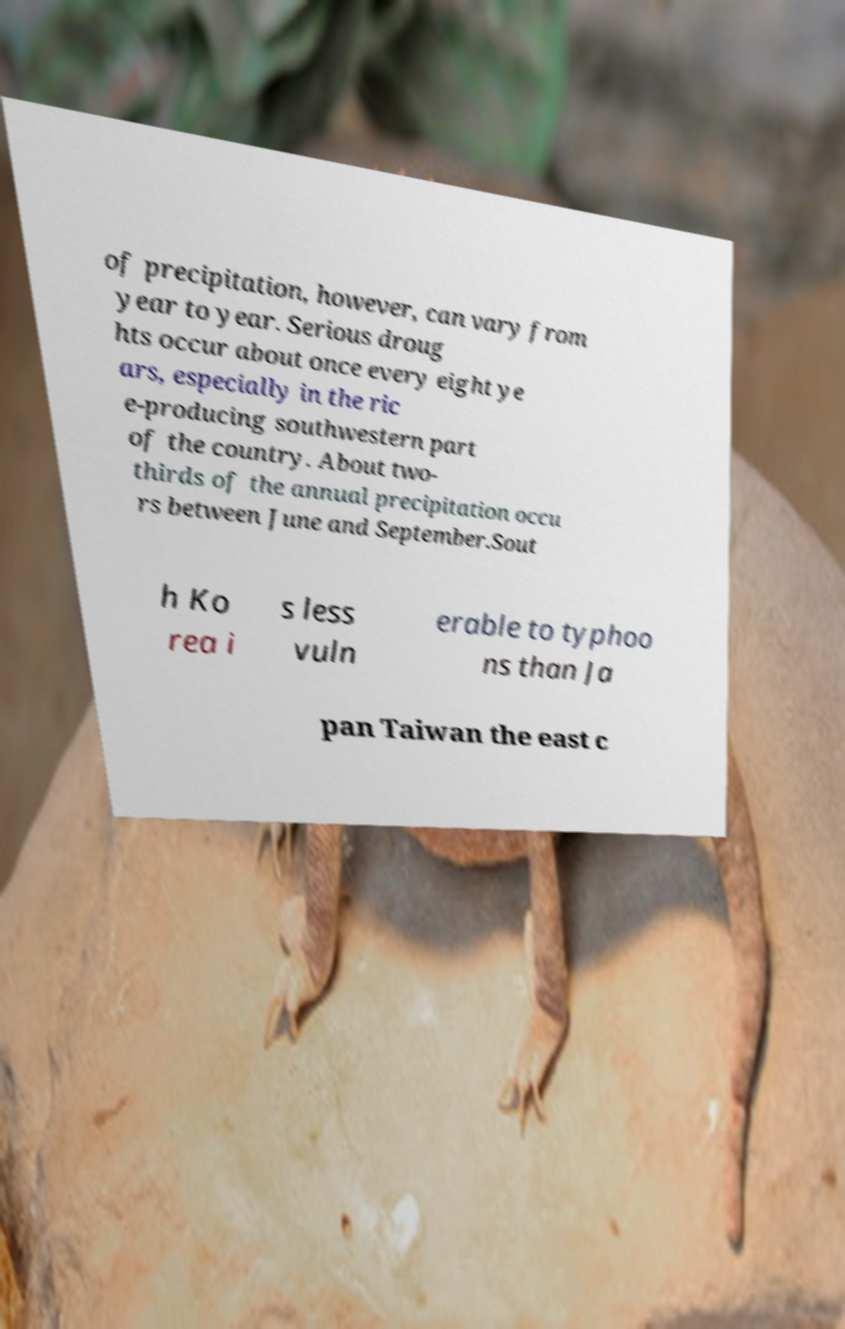Please identify and transcribe the text found in this image. of precipitation, however, can vary from year to year. Serious droug hts occur about once every eight ye ars, especially in the ric e-producing southwestern part of the country. About two- thirds of the annual precipitation occu rs between June and September.Sout h Ko rea i s less vuln erable to typhoo ns than Ja pan Taiwan the east c 